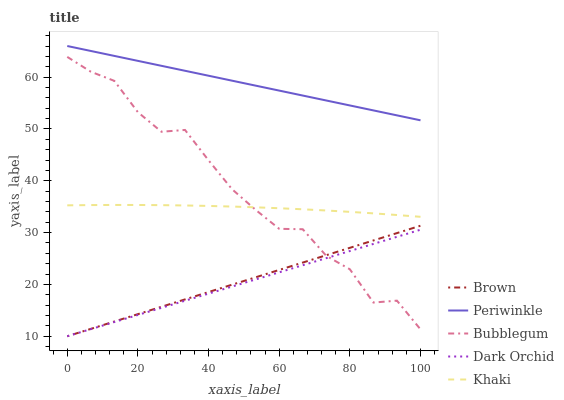Does Dark Orchid have the minimum area under the curve?
Answer yes or no. Yes. Does Periwinkle have the maximum area under the curve?
Answer yes or no. Yes. Does Khaki have the minimum area under the curve?
Answer yes or no. No. Does Khaki have the maximum area under the curve?
Answer yes or no. No. Is Dark Orchid the smoothest?
Answer yes or no. Yes. Is Bubblegum the roughest?
Answer yes or no. Yes. Is Khaki the smoothest?
Answer yes or no. No. Is Khaki the roughest?
Answer yes or no. No. Does Khaki have the lowest value?
Answer yes or no. No. Does Periwinkle have the highest value?
Answer yes or no. Yes. Does Khaki have the highest value?
Answer yes or no. No. Is Dark Orchid less than Periwinkle?
Answer yes or no. Yes. Is Periwinkle greater than Khaki?
Answer yes or no. Yes. Does Brown intersect Bubblegum?
Answer yes or no. Yes. Is Brown less than Bubblegum?
Answer yes or no. No. Is Brown greater than Bubblegum?
Answer yes or no. No. Does Dark Orchid intersect Periwinkle?
Answer yes or no. No. 